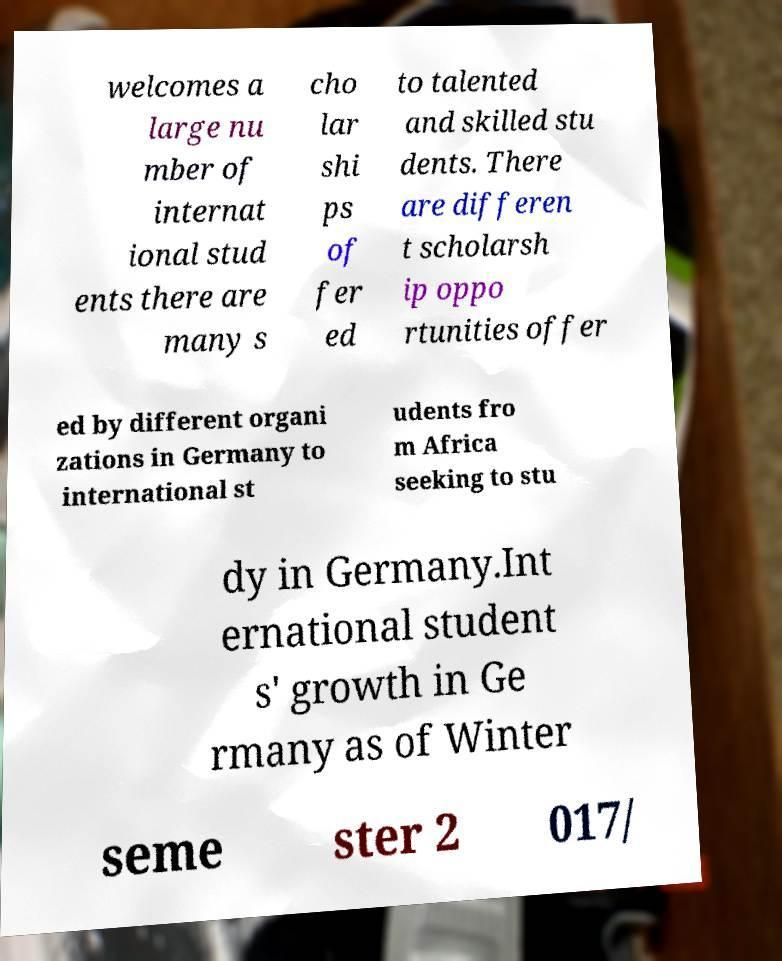Can you accurately transcribe the text from the provided image for me? welcomes a large nu mber of internat ional stud ents there are many s cho lar shi ps of fer ed to talented and skilled stu dents. There are differen t scholarsh ip oppo rtunities offer ed by different organi zations in Germany to international st udents fro m Africa seeking to stu dy in Germany.Int ernational student s' growth in Ge rmany as of Winter seme ster 2 017/ 